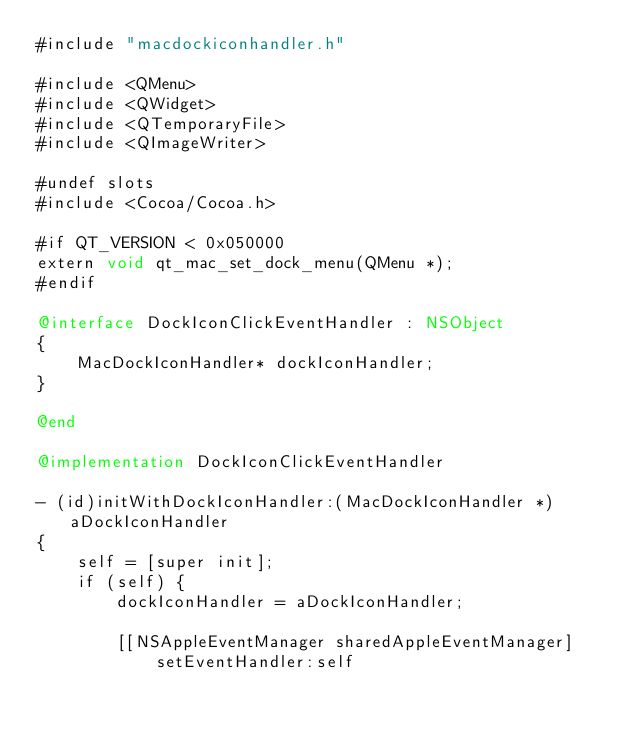Convert code to text. <code><loc_0><loc_0><loc_500><loc_500><_ObjectiveC_>#include "macdockiconhandler.h"

#include <QMenu>
#include <QWidget>
#include <QTemporaryFile>
#include <QImageWriter>

#undef slots
#include <Cocoa/Cocoa.h>

#if QT_VERSION < 0x050000
extern void qt_mac_set_dock_menu(QMenu *);
#endif

@interface DockIconClickEventHandler : NSObject
{
    MacDockIconHandler* dockIconHandler;
}

@end

@implementation DockIconClickEventHandler

- (id)initWithDockIconHandler:(MacDockIconHandler *)aDockIconHandler
{
    self = [super init];
    if (self) {
        dockIconHandler = aDockIconHandler;

        [[NSAppleEventManager sharedAppleEventManager]
            setEventHandler:self</code> 